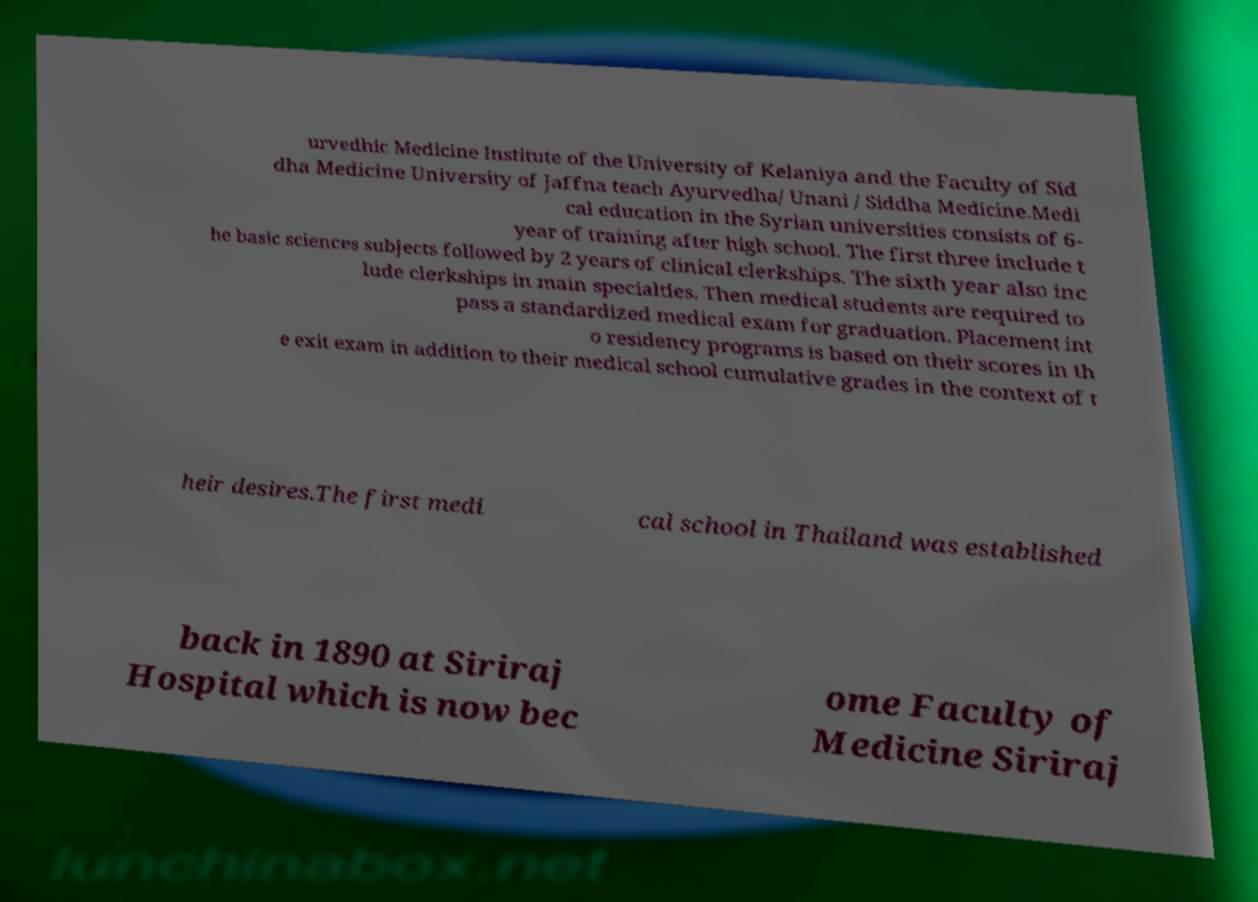Please identify and transcribe the text found in this image. urvedhic Medicine Institute of the University of Kelaniya and the Faculty of Sid dha Medicine University of Jaffna teach Ayurvedha/ Unani / Siddha Medicine.Medi cal education in the Syrian universities consists of 6- year of training after high school. The first three include t he basic sciences subjects followed by 2 years of clinical clerkships. The sixth year also inc lude clerkships in main specialties. Then medical students are required to pass a standardized medical exam for graduation. Placement int o residency programs is based on their scores in th e exit exam in addition to their medical school cumulative grades in the context of t heir desires.The first medi cal school in Thailand was established back in 1890 at Siriraj Hospital which is now bec ome Faculty of Medicine Siriraj 